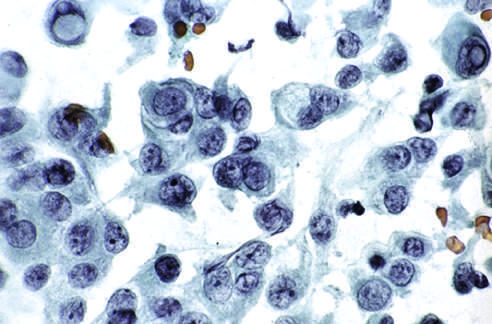s wilms tumor visible in some of the aspirated cells?
Answer the question using a single word or phrase. No 